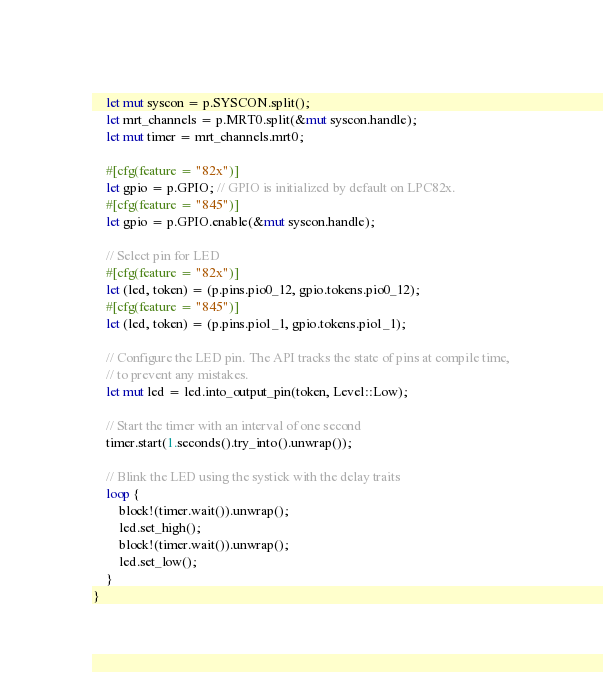<code> <loc_0><loc_0><loc_500><loc_500><_Rust_>    let mut syscon = p.SYSCON.split();
    let mrt_channels = p.MRT0.split(&mut syscon.handle);
    let mut timer = mrt_channels.mrt0;

    #[cfg(feature = "82x")]
    let gpio = p.GPIO; // GPIO is initialized by default on LPC82x.
    #[cfg(feature = "845")]
    let gpio = p.GPIO.enable(&mut syscon.handle);

    // Select pin for LED
    #[cfg(feature = "82x")]
    let (led, token) = (p.pins.pio0_12, gpio.tokens.pio0_12);
    #[cfg(feature = "845")]
    let (led, token) = (p.pins.pio1_1, gpio.tokens.pio1_1);

    // Configure the LED pin. The API tracks the state of pins at compile time,
    // to prevent any mistakes.
    let mut led = led.into_output_pin(token, Level::Low);

    // Start the timer with an interval of one second
    timer.start(1.seconds().try_into().unwrap());

    // Blink the LED using the systick with the delay traits
    loop {
        block!(timer.wait()).unwrap();
        led.set_high();
        block!(timer.wait()).unwrap();
        led.set_low();
    }
}
</code> 